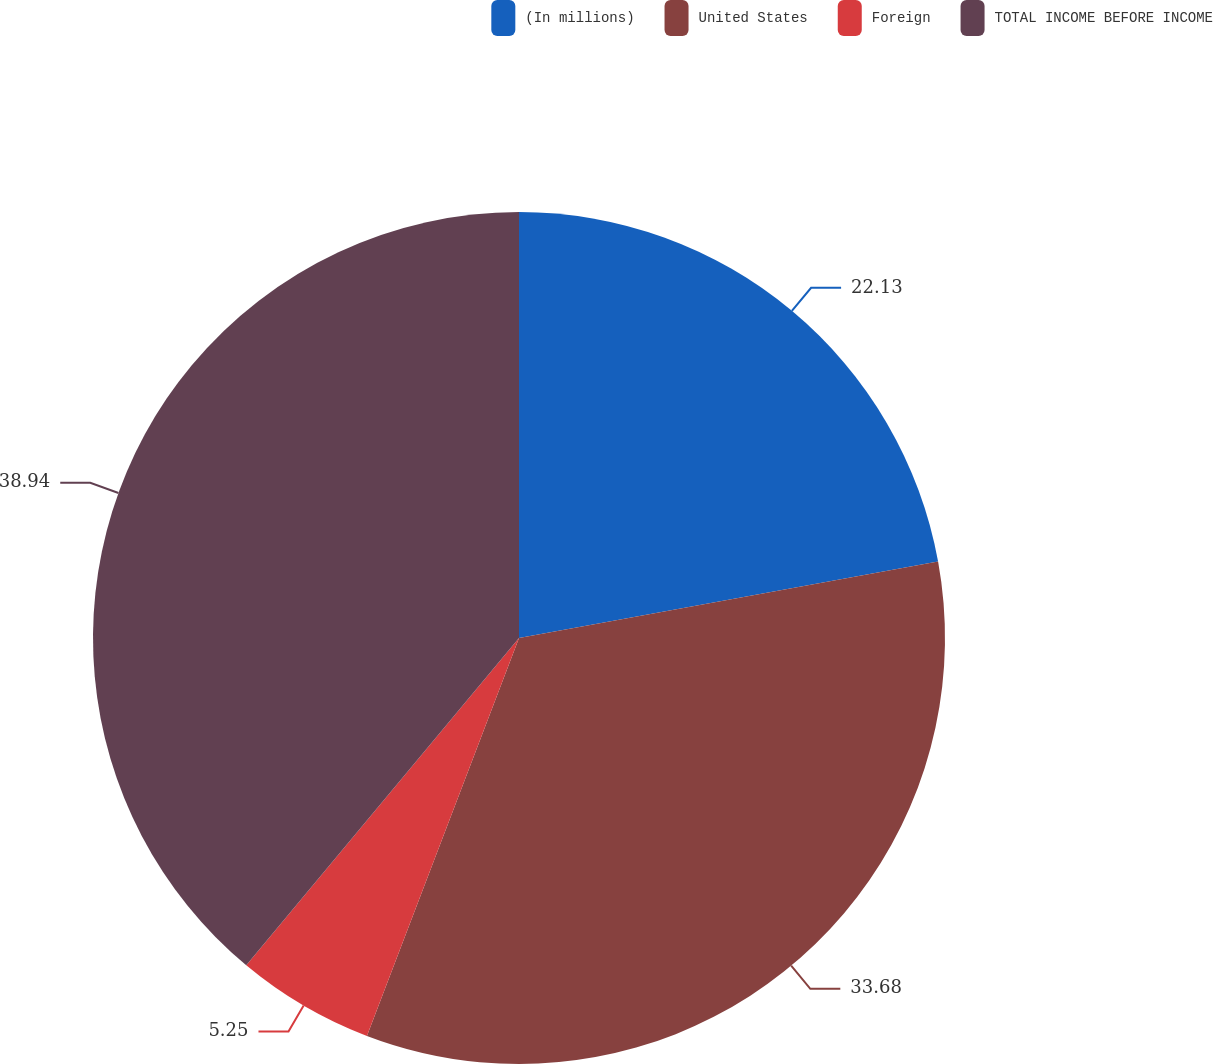<chart> <loc_0><loc_0><loc_500><loc_500><pie_chart><fcel>(In millions)<fcel>United States<fcel>Foreign<fcel>TOTAL INCOME BEFORE INCOME<nl><fcel>22.13%<fcel>33.68%<fcel>5.25%<fcel>38.94%<nl></chart> 